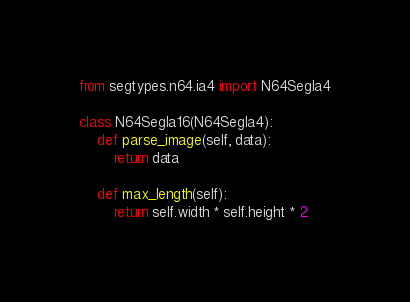Convert code to text. <code><loc_0><loc_0><loc_500><loc_500><_Python_>from segtypes.n64.ia4 import N64SegIa4

class N64SegIa16(N64SegIa4):
    def parse_image(self, data):
        return data

    def max_length(self):
        return self.width * self.height * 2
</code> 